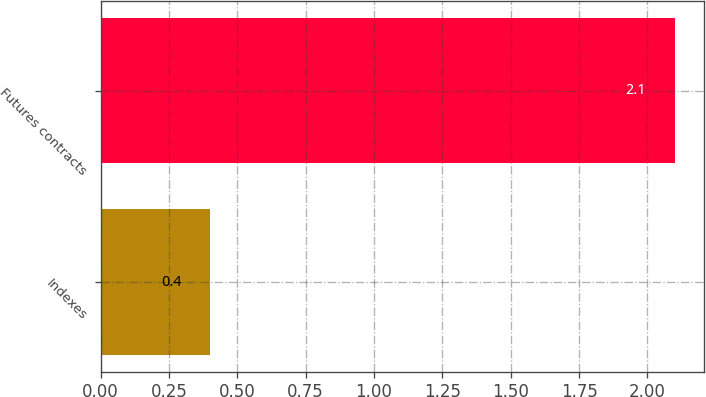<chart> <loc_0><loc_0><loc_500><loc_500><bar_chart><fcel>Indexes<fcel>Futures contracts<nl><fcel>0.4<fcel>2.1<nl></chart> 